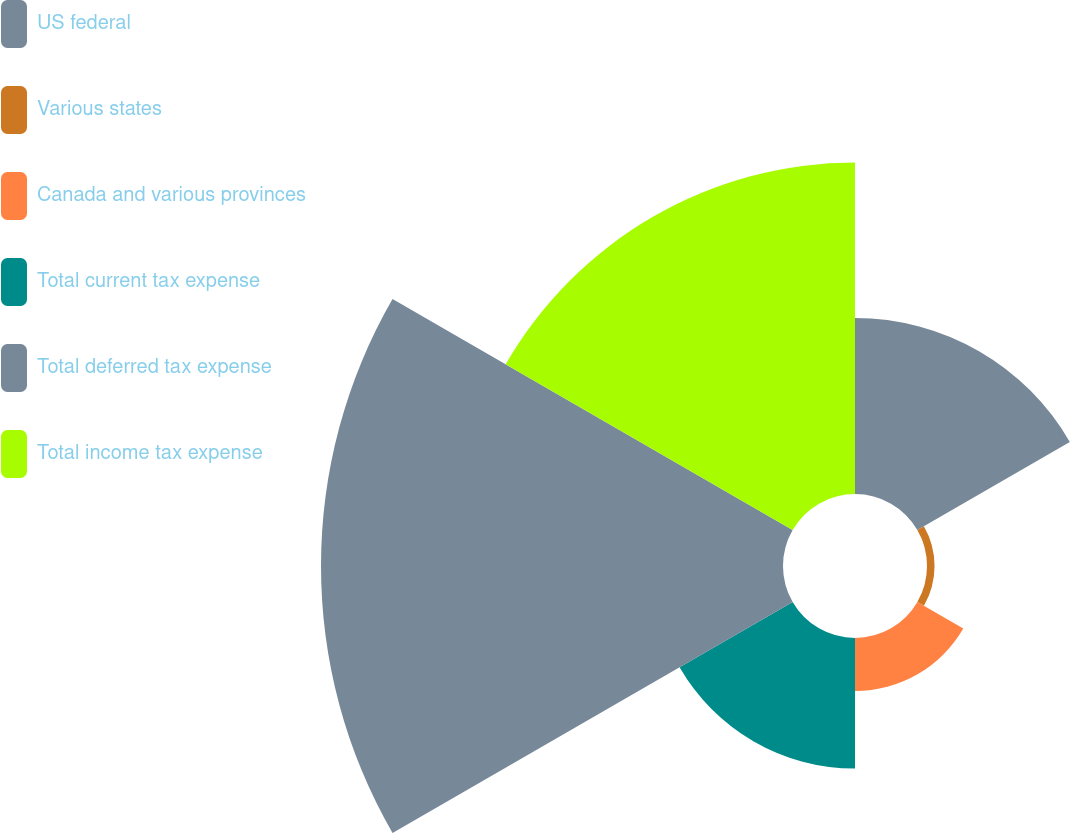<chart> <loc_0><loc_0><loc_500><loc_500><pie_chart><fcel>US federal<fcel>Various states<fcel>Canada and various provinces<fcel>Total current tax expense<fcel>Total deferred tax expense<fcel>Total income tax expense<nl><fcel>15.17%<fcel>0.65%<fcel>4.57%<fcel>11.25%<fcel>39.81%<fcel>28.56%<nl></chart> 